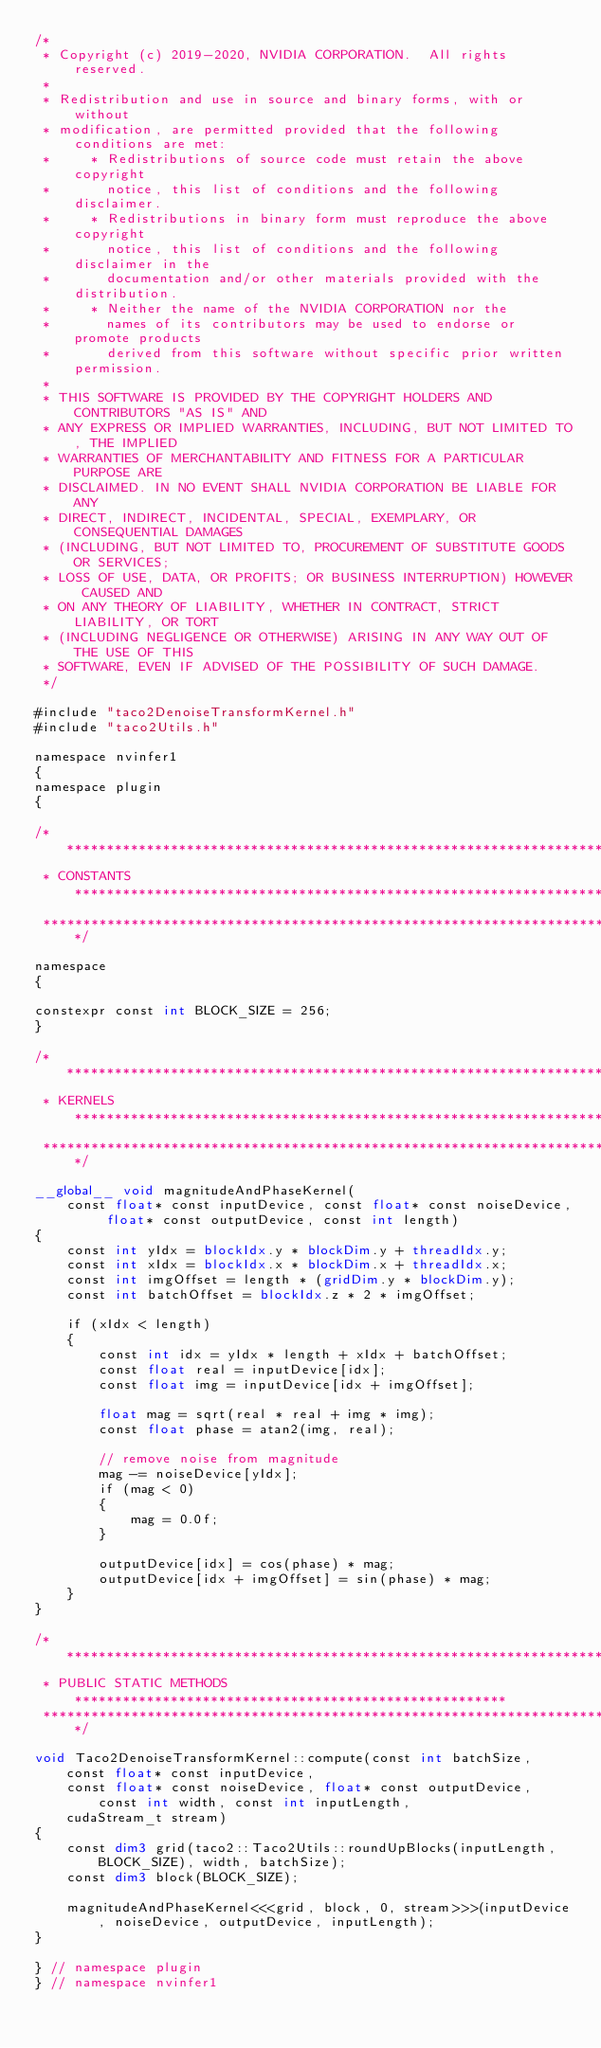Convert code to text. <code><loc_0><loc_0><loc_500><loc_500><_Cuda_>/*
 * Copyright (c) 2019-2020, NVIDIA CORPORATION.  All rights reserved.
 *
 * Redistribution and use in source and binary forms, with or without
 * modification, are permitted provided that the following conditions are met:
 *     * Redistributions of source code must retain the above copyright
 *       notice, this list of conditions and the following disclaimer.
 *     * Redistributions in binary form must reproduce the above copyright
 *       notice, this list of conditions and the following disclaimer in the
 *       documentation and/or other materials provided with the distribution.
 *     * Neither the name of the NVIDIA CORPORATION nor the
 *       names of its contributors may be used to endorse or promote products
 *       derived from this software without specific prior written permission.
 *
 * THIS SOFTWARE IS PROVIDED BY THE COPYRIGHT HOLDERS AND CONTRIBUTORS "AS IS" AND
 * ANY EXPRESS OR IMPLIED WARRANTIES, INCLUDING, BUT NOT LIMITED TO, THE IMPLIED
 * WARRANTIES OF MERCHANTABILITY AND FITNESS FOR A PARTICULAR PURPOSE ARE
 * DISCLAIMED. IN NO EVENT SHALL NVIDIA CORPORATION BE LIABLE FOR ANY
 * DIRECT, INDIRECT, INCIDENTAL, SPECIAL, EXEMPLARY, OR CONSEQUENTIAL DAMAGES
 * (INCLUDING, BUT NOT LIMITED TO, PROCUREMENT OF SUBSTITUTE GOODS OR SERVICES;
 * LOSS OF USE, DATA, OR PROFITS; OR BUSINESS INTERRUPTION) HOWEVER CAUSED AND
 * ON ANY THEORY OF LIABILITY, WHETHER IN CONTRACT, STRICT LIABILITY, OR TORT
 * (INCLUDING NEGLIGENCE OR OTHERWISE) ARISING IN ANY WAY OUT OF THE USE OF THIS
 * SOFTWARE, EVEN IF ADVISED OF THE POSSIBILITY OF SUCH DAMAGE.
 */

#include "taco2DenoiseTransformKernel.h"
#include "taco2Utils.h"

namespace nvinfer1
{
namespace plugin
{

/******************************************************************************
 * CONSTANTS ******************************************************************
 *****************************************************************************/

namespace
{

constexpr const int BLOCK_SIZE = 256;
}

/******************************************************************************
 * KERNELS ********************************************************************
 *****************************************************************************/

__global__ void magnitudeAndPhaseKernel(
    const float* const inputDevice, const float* const noiseDevice, float* const outputDevice, const int length)
{
    const int yIdx = blockIdx.y * blockDim.y + threadIdx.y;
    const int xIdx = blockIdx.x * blockDim.x + threadIdx.x;
    const int imgOffset = length * (gridDim.y * blockDim.y);
    const int batchOffset = blockIdx.z * 2 * imgOffset;

    if (xIdx < length)
    {
        const int idx = yIdx * length + xIdx + batchOffset;
        const float real = inputDevice[idx];
        const float img = inputDevice[idx + imgOffset];

        float mag = sqrt(real * real + img * img);
        const float phase = atan2(img, real);

        // remove noise from magnitude
        mag -= noiseDevice[yIdx];
        if (mag < 0)
        {
            mag = 0.0f;
        }

        outputDevice[idx] = cos(phase) * mag;
        outputDevice[idx + imgOffset] = sin(phase) * mag;
    }
}

/******************************************************************************
 * PUBLIC STATIC METHODS ******************************************************
 *****************************************************************************/

void Taco2DenoiseTransformKernel::compute(const int batchSize, const float* const inputDevice,
    const float* const noiseDevice, float* const outputDevice, const int width, const int inputLength,
    cudaStream_t stream)
{
    const dim3 grid(taco2::Taco2Utils::roundUpBlocks(inputLength, BLOCK_SIZE), width, batchSize);
    const dim3 block(BLOCK_SIZE);

    magnitudeAndPhaseKernel<<<grid, block, 0, stream>>>(inputDevice, noiseDevice, outputDevice, inputLength);
}

} // namespace plugin
} // namespace nvinfer1
</code> 